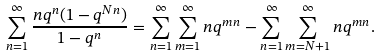<formula> <loc_0><loc_0><loc_500><loc_500>\sum _ { n = 1 } ^ { \infty } \frac { n q ^ { n } ( 1 - q ^ { N n } ) } { 1 - q ^ { n } } & = \sum _ { n = 1 } ^ { \infty } \sum _ { m = 1 } ^ { \infty } n q ^ { m n } - \sum _ { n = 1 } ^ { \infty } \sum _ { m = N + 1 } ^ { \infty } n q ^ { m n } .</formula> 